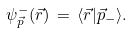<formula> <loc_0><loc_0><loc_500><loc_500>\psi _ { \vec { p } } ^ { - } ( \vec { r } ) \, = \, \langle \vec { r } | \vec { p } _ { - } \rangle .</formula> 